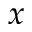<formula> <loc_0><loc_0><loc_500><loc_500>x</formula> 